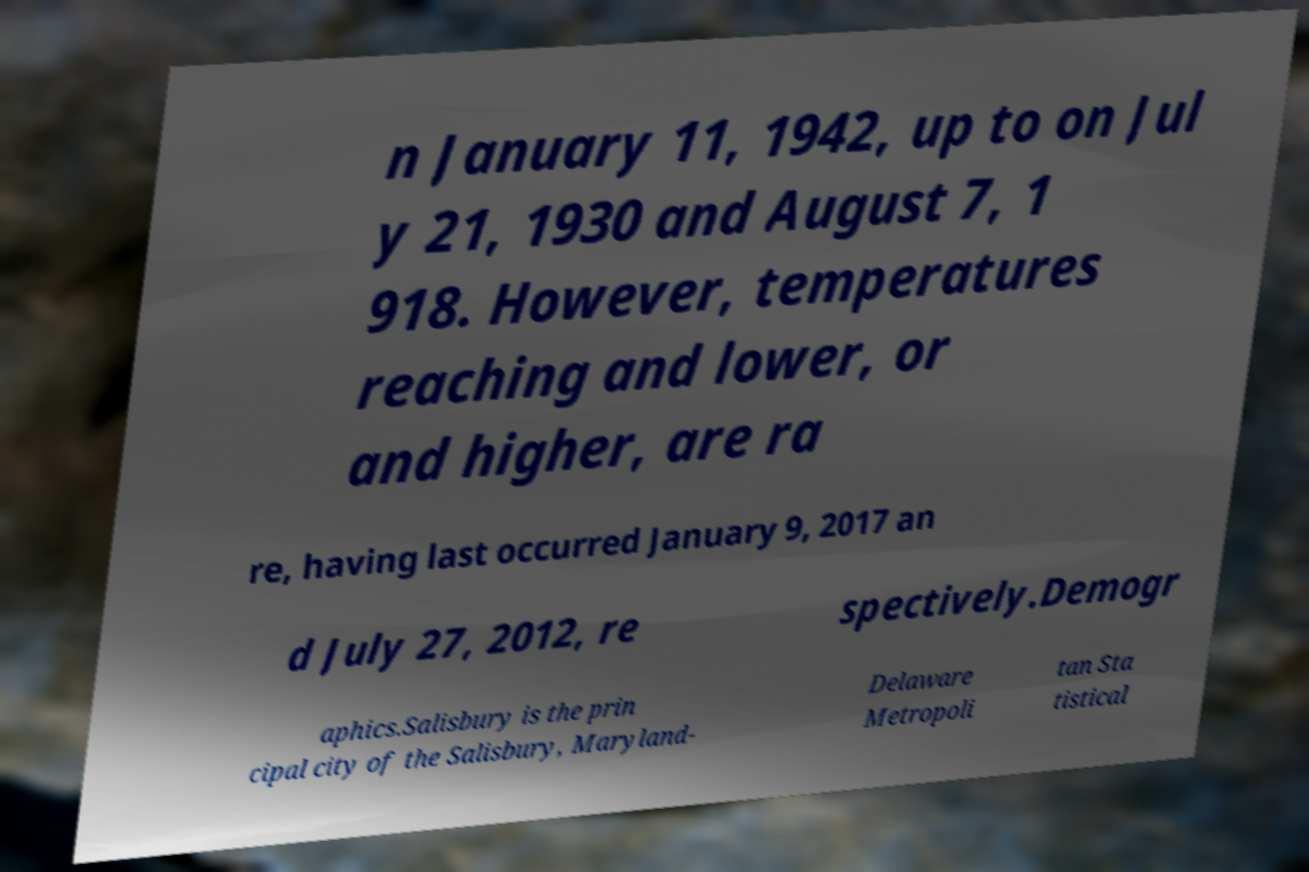I need the written content from this picture converted into text. Can you do that? n January 11, 1942, up to on Jul y 21, 1930 and August 7, 1 918. However, temperatures reaching and lower, or and higher, are ra re, having last occurred January 9, 2017 an d July 27, 2012, re spectively.Demogr aphics.Salisbury is the prin cipal city of the Salisbury, Maryland- Delaware Metropoli tan Sta tistical 